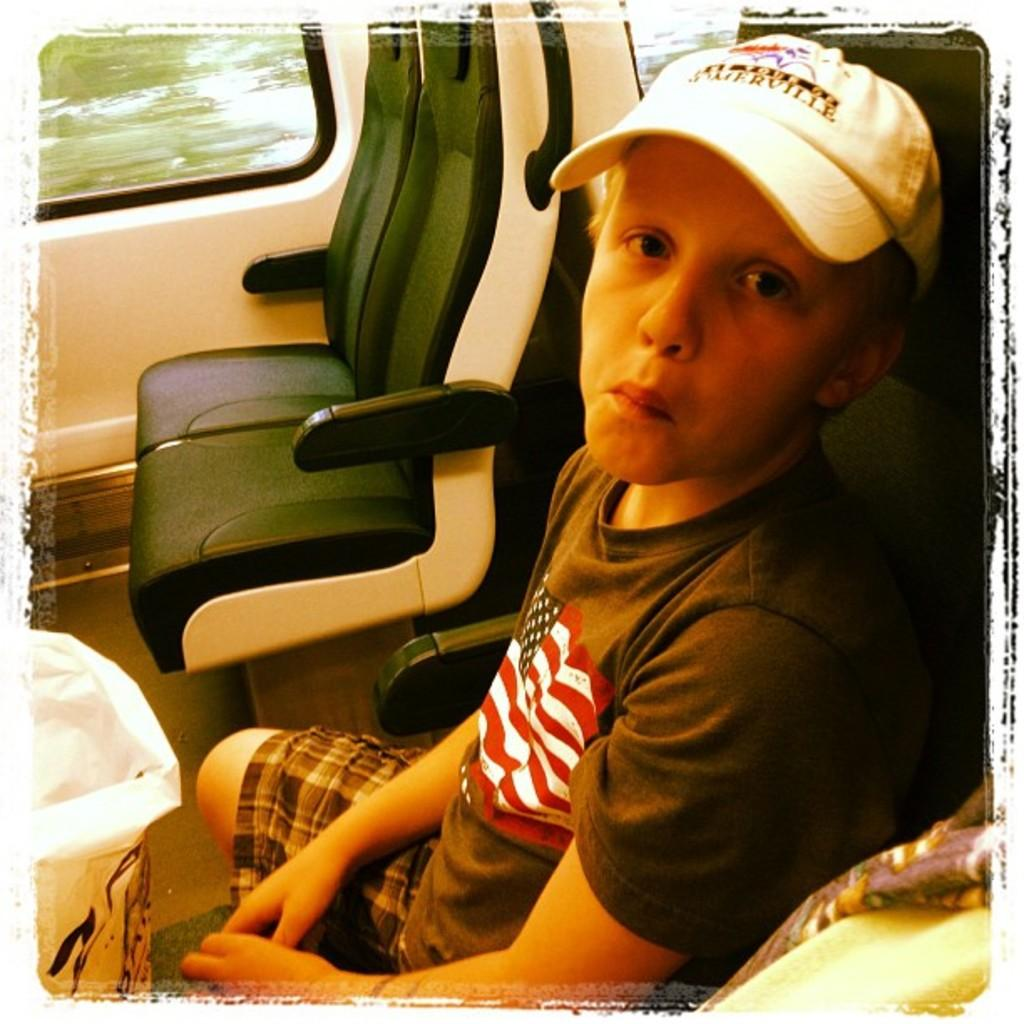What is the person in the image doing? The person is sitting inside the vehicle. Can you describe the person's attire? The person is wearing a dress and a cap. What else can be seen in the image? There is a bag visible in the image. What feature of the vehicle can be seen in the image? There is a window visible in the image. What type of donkey can be seen playing with a doll in the image? There is no donkey or doll present in the image. What property does the person own based on the image? The image does not provide information about the person's property ownership. 